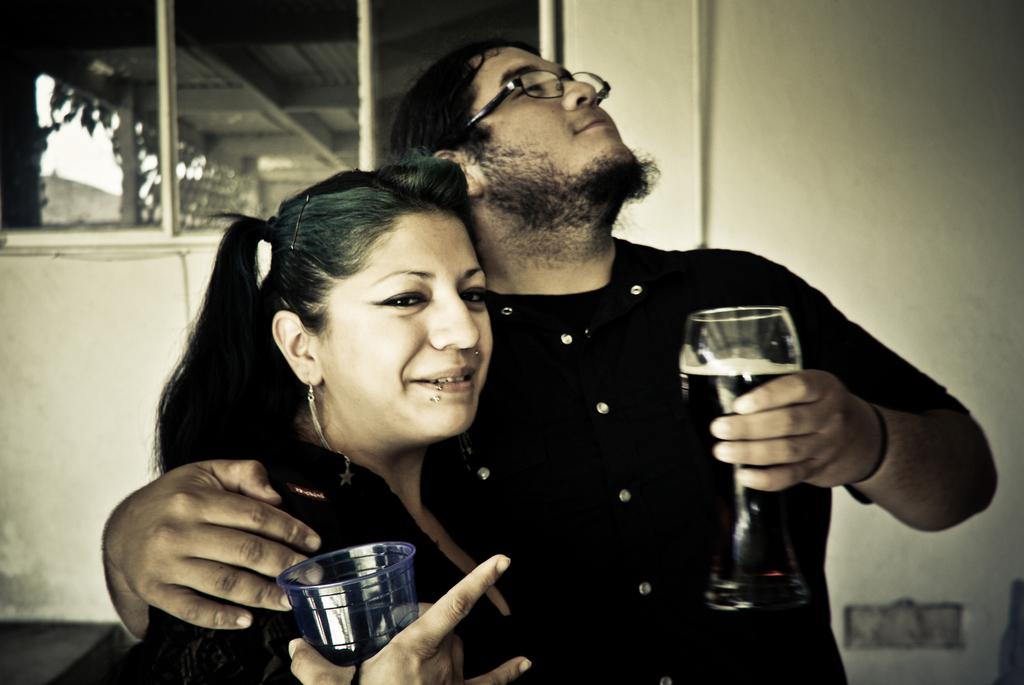What can be seen in the background of the image? There is a wall and windows in the background of the image. What are the man and woman holding in their hands? The man and woman are both holding a glass in their hands. What is the man wearing in the image? The man is wearing spectacles. Can you describe the woman's appearance in the image? The provided facts do not mention any specific details about the woman's appearance, other than her holding a glass. What type of insurance policy is the man discussing with the woman in the image? There is no indication in the image that the man and woman are discussing insurance or any other topic. 